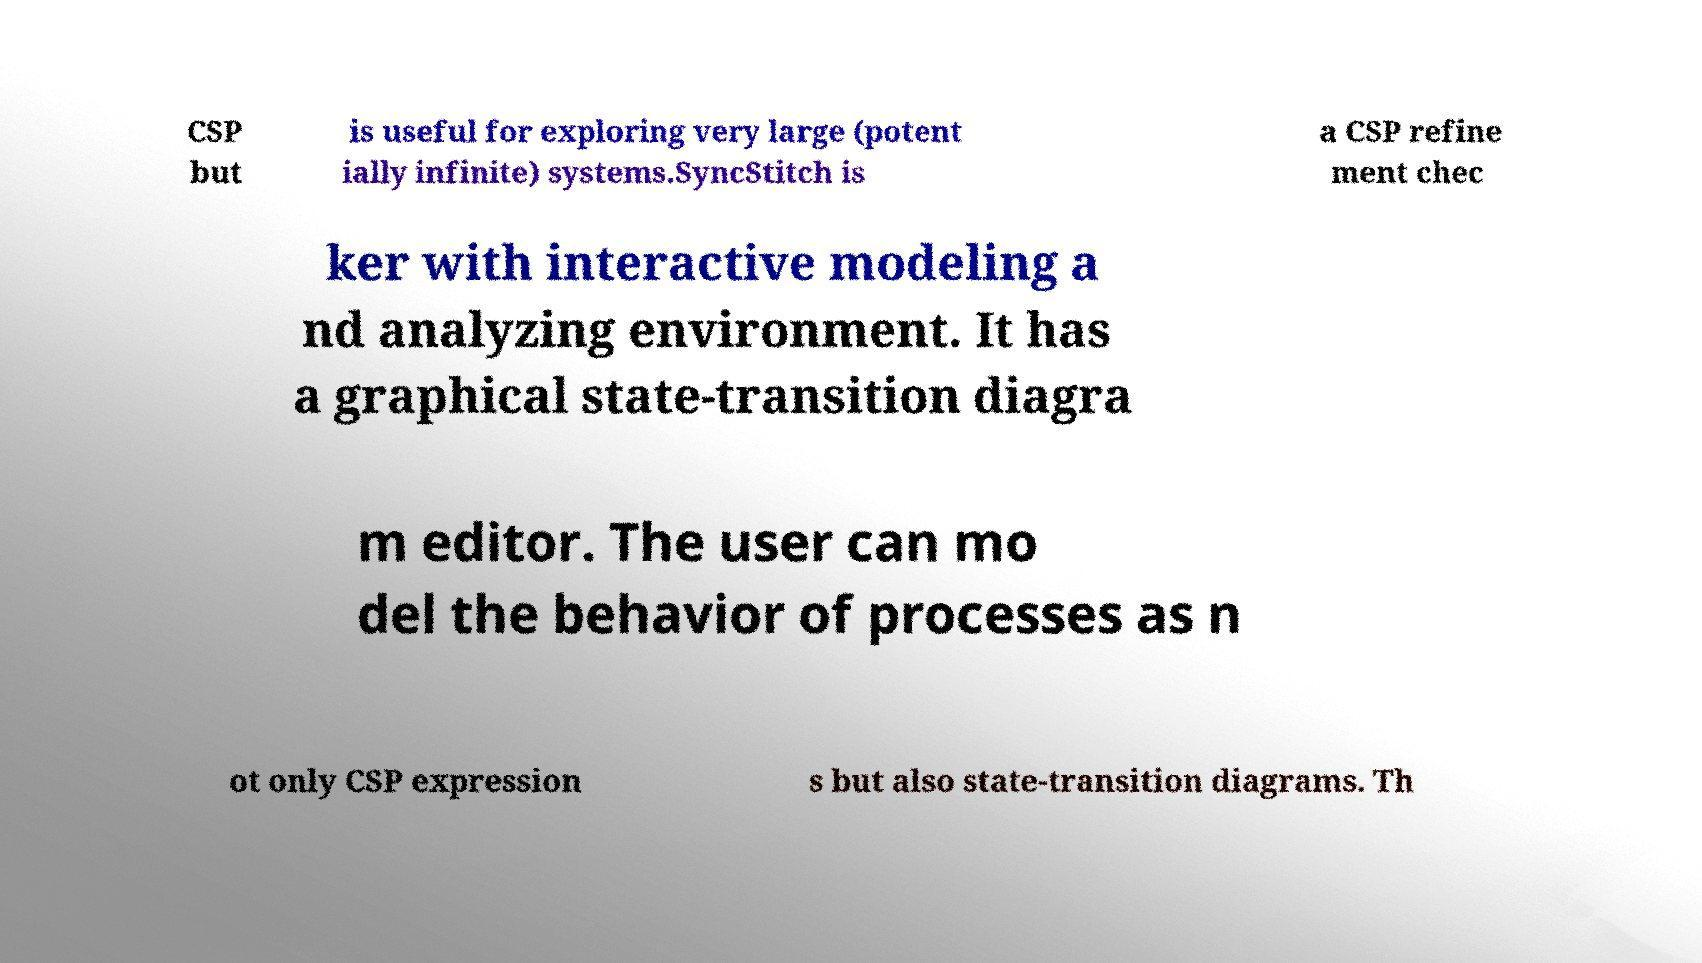There's text embedded in this image that I need extracted. Can you transcribe it verbatim? CSP but is useful for exploring very large (potent ially infinite) systems.SyncStitch is a CSP refine ment chec ker with interactive modeling a nd analyzing environment. It has a graphical state-transition diagra m editor. The user can mo del the behavior of processes as n ot only CSP expression s but also state-transition diagrams. Th 